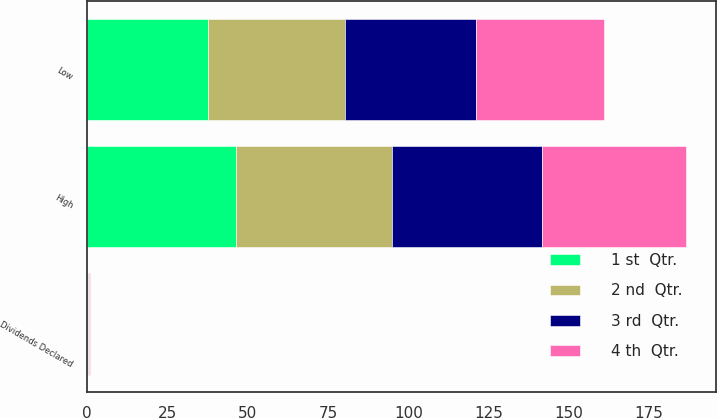<chart> <loc_0><loc_0><loc_500><loc_500><stacked_bar_chart><ecel><fcel>High<fcel>Low<fcel>Dividends Declared<nl><fcel>1 st  Qtr.<fcel>46.31<fcel>37.63<fcel>0.21<nl><fcel>3 rd  Qtr.<fcel>46.8<fcel>40.98<fcel>0.21<nl><fcel>4 th  Qtr.<fcel>44.77<fcel>39.85<fcel>0.21<nl><fcel>2 nd  Qtr.<fcel>48.58<fcel>42.5<fcel>0.23<nl></chart> 